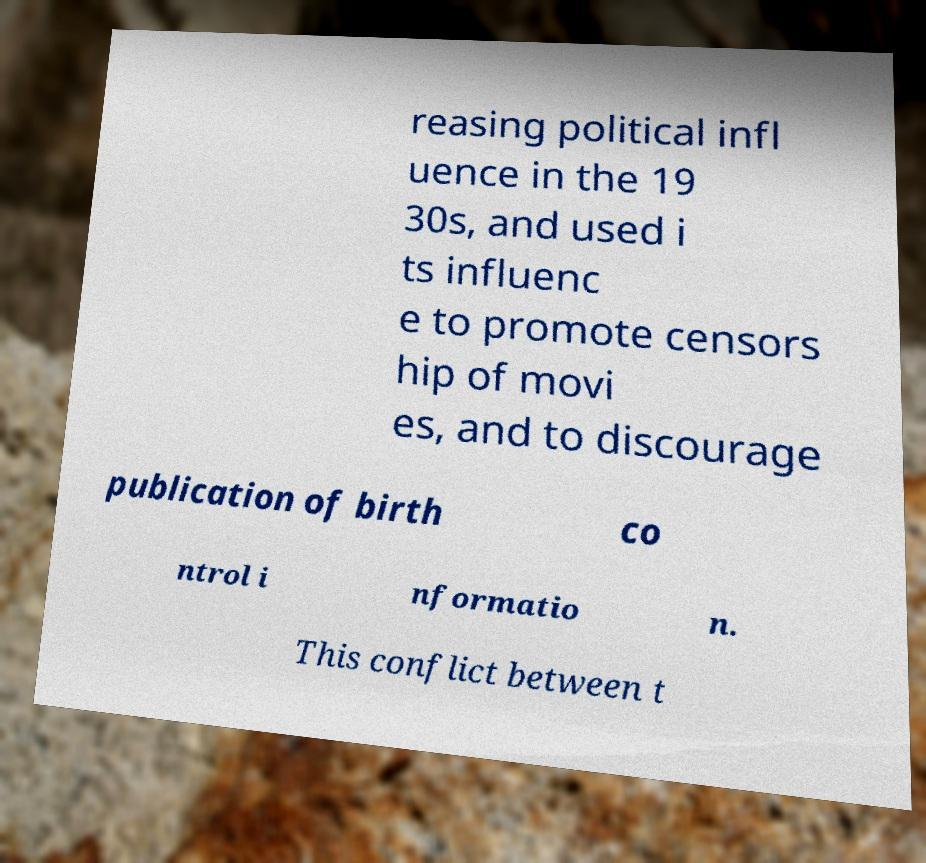I need the written content from this picture converted into text. Can you do that? reasing political infl uence in the 19 30s, and used i ts influenc e to promote censors hip of movi es, and to discourage publication of birth co ntrol i nformatio n. This conflict between t 